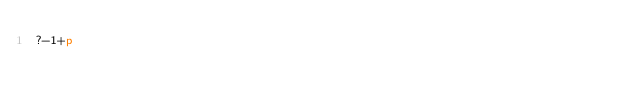<code> <loc_0><loc_0><loc_500><loc_500><_dc_>?-1+p</code> 